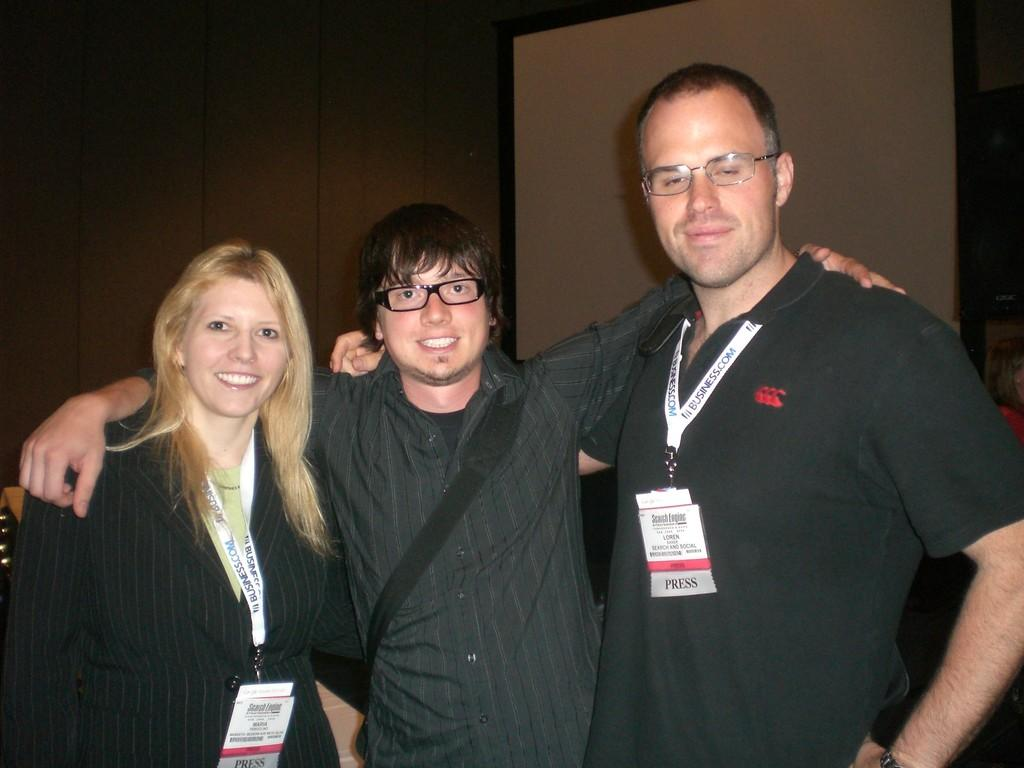Where was the image taken? The image was taken indoors. What can be seen in the background of the image? There is a wall in the background of the image. How many people are in the image? Two men and a woman are standing in the middle of the image. What is the facial expression of the individuals in the image? The individuals in the image have smiling faces. What type of seed can be seen growing on the wall in the image? There is no seed growing on the wall in the image; it only shows two men and a woman with smiling faces. 